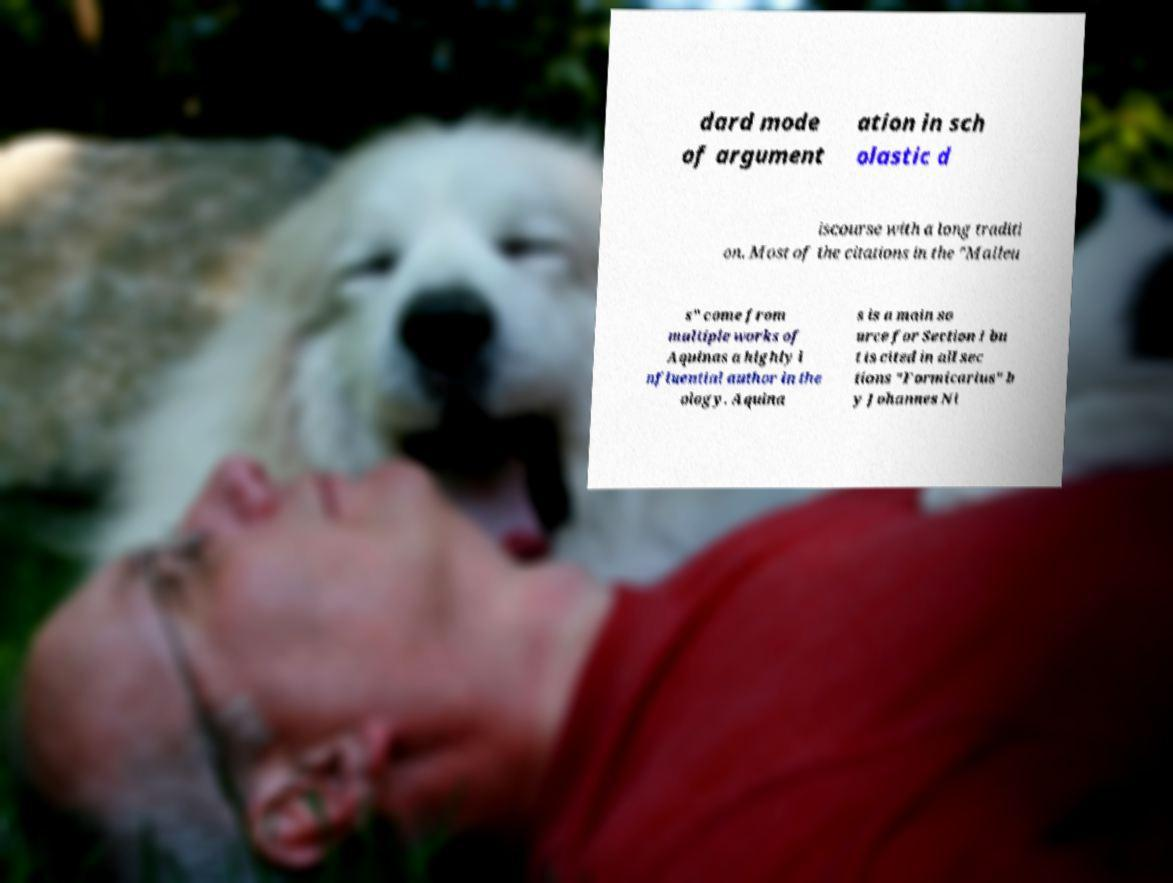Please identify and transcribe the text found in this image. dard mode of argument ation in sch olastic d iscourse with a long traditi on. Most of the citations in the "Malleu s" come from multiple works of Aquinas a highly i nfluential author in the ology. Aquina s is a main so urce for Section I bu t is cited in all sec tions "Formicarius" b y Johannes Ni 